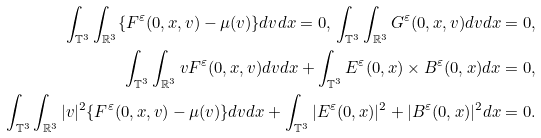Convert formula to latex. <formula><loc_0><loc_0><loc_500><loc_500>\int _ { \mathbb { T } ^ { 3 } } \int _ { \mathbb { R } ^ { 3 } } \{ F ^ { \varepsilon } ( 0 , x , v ) - \mu ( v ) \} d v d x = 0 , \, \int _ { \mathbb { T } ^ { 3 } } \int _ { \mathbb { R } ^ { 3 } } G ^ { \varepsilon } ( 0 , x , v ) d v d x = 0 , \\ \int _ { \mathbb { T } ^ { 3 } } \int _ { \mathbb { R } ^ { 3 } } v F ^ { \varepsilon } ( 0 , x , v ) d v d x + \int _ { \mathbb { T } ^ { 3 } } E ^ { \varepsilon } ( 0 , x ) \times B ^ { \varepsilon } ( 0 , x ) d x = 0 , \\ \int _ { \mathbb { T } ^ { 3 } } \int _ { \mathbb { R } ^ { 3 } } | v | ^ { 2 } \{ F ^ { \varepsilon } ( 0 , x , v ) - \mu ( v ) \} d v d x + \int _ { \mathbb { T } ^ { 3 } } | E ^ { \varepsilon } ( 0 , x ) | ^ { 2 } + | B ^ { \varepsilon } ( 0 , x ) | ^ { 2 } d x = 0 .</formula> 